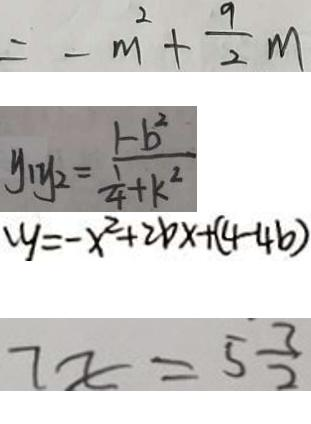Convert formula to latex. <formula><loc_0><loc_0><loc_500><loc_500>= - m ^ { 2 } + \frac { 9 } { 2 } m 
 y _ { 1 } y _ { 2 } = \frac { 1 - b ^ { 2 } } { \frac { 1 } { 4 } + k ^ { 2 } } 
 y = - x ^ { 2 } + 2 b x + ( 4 - 4 b ) 
 7 x = 5 \frac { 3 } { 2 }</formula> 